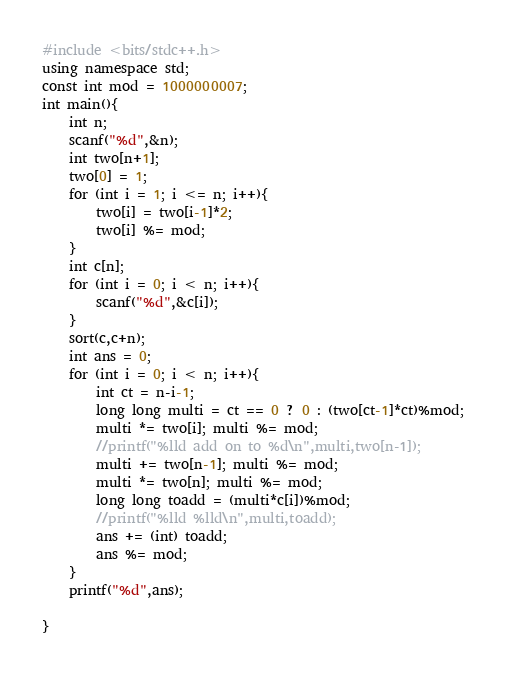<code> <loc_0><loc_0><loc_500><loc_500><_C++_>#include <bits/stdc++.h>
using namespace std;
const int mod = 1000000007;
int main(){
    int n;
    scanf("%d",&n);
    int two[n+1];
    two[0] = 1;
    for (int i = 1; i <= n; i++){
        two[i] = two[i-1]*2;
        two[i] %= mod;
    }
    int c[n];
    for (int i = 0; i < n; i++){
        scanf("%d",&c[i]);
    }
    sort(c,c+n);
    int ans = 0;
    for (int i = 0; i < n; i++){
        int ct = n-i-1;
        long long multi = ct == 0 ? 0 : (two[ct-1]*ct)%mod;
        multi *= two[i]; multi %= mod;
        //printf("%lld add on to %d\n",multi,two[n-1]);
        multi += two[n-1]; multi %= mod;
        multi *= two[n]; multi %= mod;
        long long toadd = (multi*c[i])%mod;
        //printf("%lld %lld\n",multi,toadd);
        ans += (int) toadd;
        ans %= mod;
    }
    printf("%d",ans);

}
</code> 